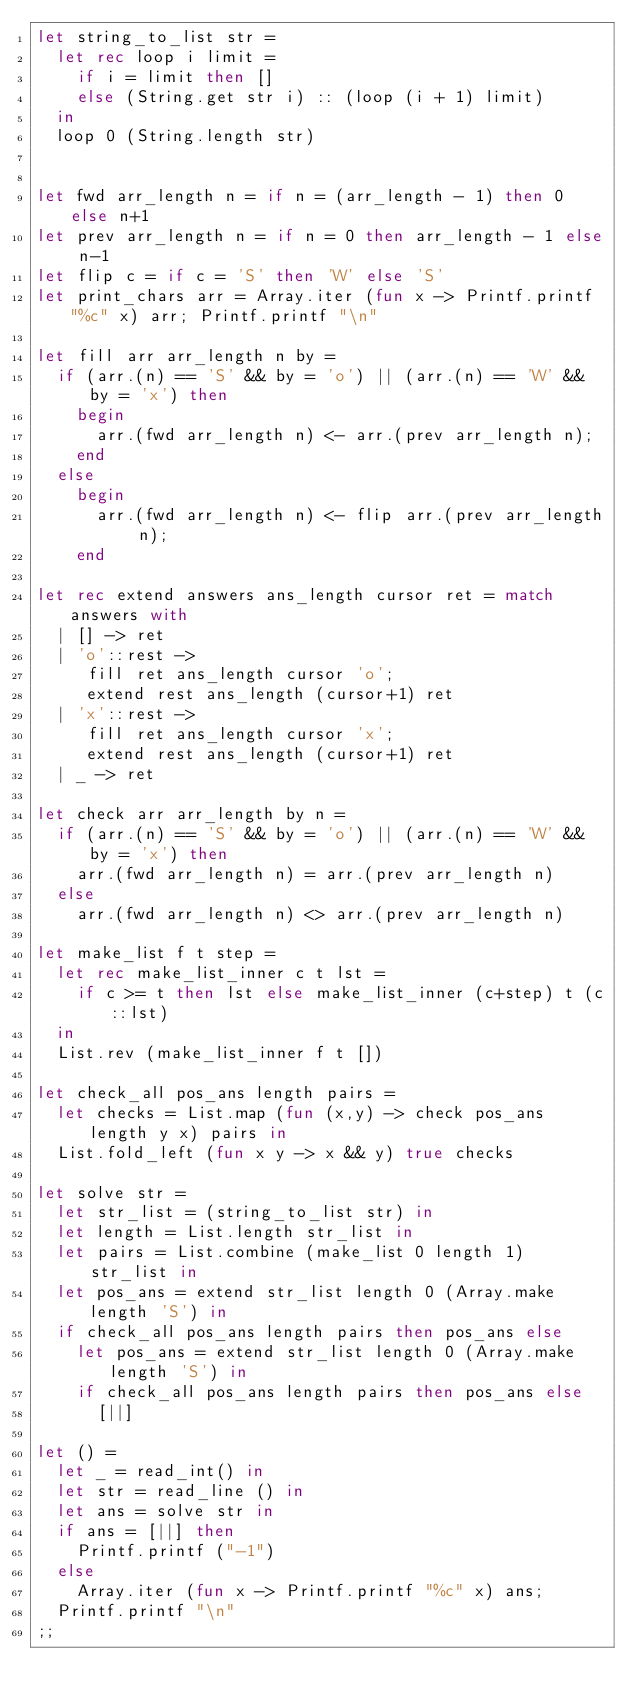<code> <loc_0><loc_0><loc_500><loc_500><_OCaml_>let string_to_list str =
  let rec loop i limit =
    if i = limit then []
    else (String.get str i) :: (loop (i + 1) limit)
  in
  loop 0 (String.length str)


let fwd arr_length n = if n = (arr_length - 1) then 0 else n+1
let prev arr_length n = if n = 0 then arr_length - 1 else n-1
let flip c = if c = 'S' then 'W' else 'S'
let print_chars arr = Array.iter (fun x -> Printf.printf "%c" x) arr; Printf.printf "\n"
           
let fill arr arr_length n by =
  if (arr.(n) == 'S' && by = 'o') || (arr.(n) == 'W' && by = 'x') then
    begin
      arr.(fwd arr_length n) <- arr.(prev arr_length n);
    end
  else
    begin
      arr.(fwd arr_length n) <- flip arr.(prev arr_length n);
    end    

let rec extend answers ans_length cursor ret = match answers with
  | [] -> ret
  | 'o'::rest ->
     fill ret ans_length cursor 'o';
     extend rest ans_length (cursor+1) ret
  | 'x'::rest ->
     fill ret ans_length cursor 'x';
     extend rest ans_length (cursor+1) ret
  | _ -> ret

let check arr arr_length by n =
  if (arr.(n) == 'S' && by = 'o') || (arr.(n) == 'W' && by = 'x') then
    arr.(fwd arr_length n) = arr.(prev arr_length n)
  else
    arr.(fwd arr_length n) <> arr.(prev arr_length n)

let make_list f t step =
  let rec make_list_inner c t lst =
    if c >= t then lst else make_list_inner (c+step) t (c::lst)
  in
  List.rev (make_list_inner f t [])

let check_all pos_ans length pairs =
  let checks = List.map (fun (x,y) -> check pos_ans length y x) pairs in
  List.fold_left (fun x y -> x && y) true checks

let solve str =
  let str_list = (string_to_list str) in
  let length = List.length str_list in
  let pairs = List.combine (make_list 0 length 1) str_list in
  let pos_ans = extend str_list length 0 (Array.make length 'S') in
  if check_all pos_ans length pairs then pos_ans else
    let pos_ans = extend str_list length 0 (Array.make length 'S') in
    if check_all pos_ans length pairs then pos_ans else
      [||]
  
let () =
  let _ = read_int() in
  let str = read_line () in
  let ans = solve str in
  if ans = [||] then
    Printf.printf ("-1")
  else
    Array.iter (fun x -> Printf.printf "%c" x) ans;
  Printf.printf "\n"
;;
</code> 